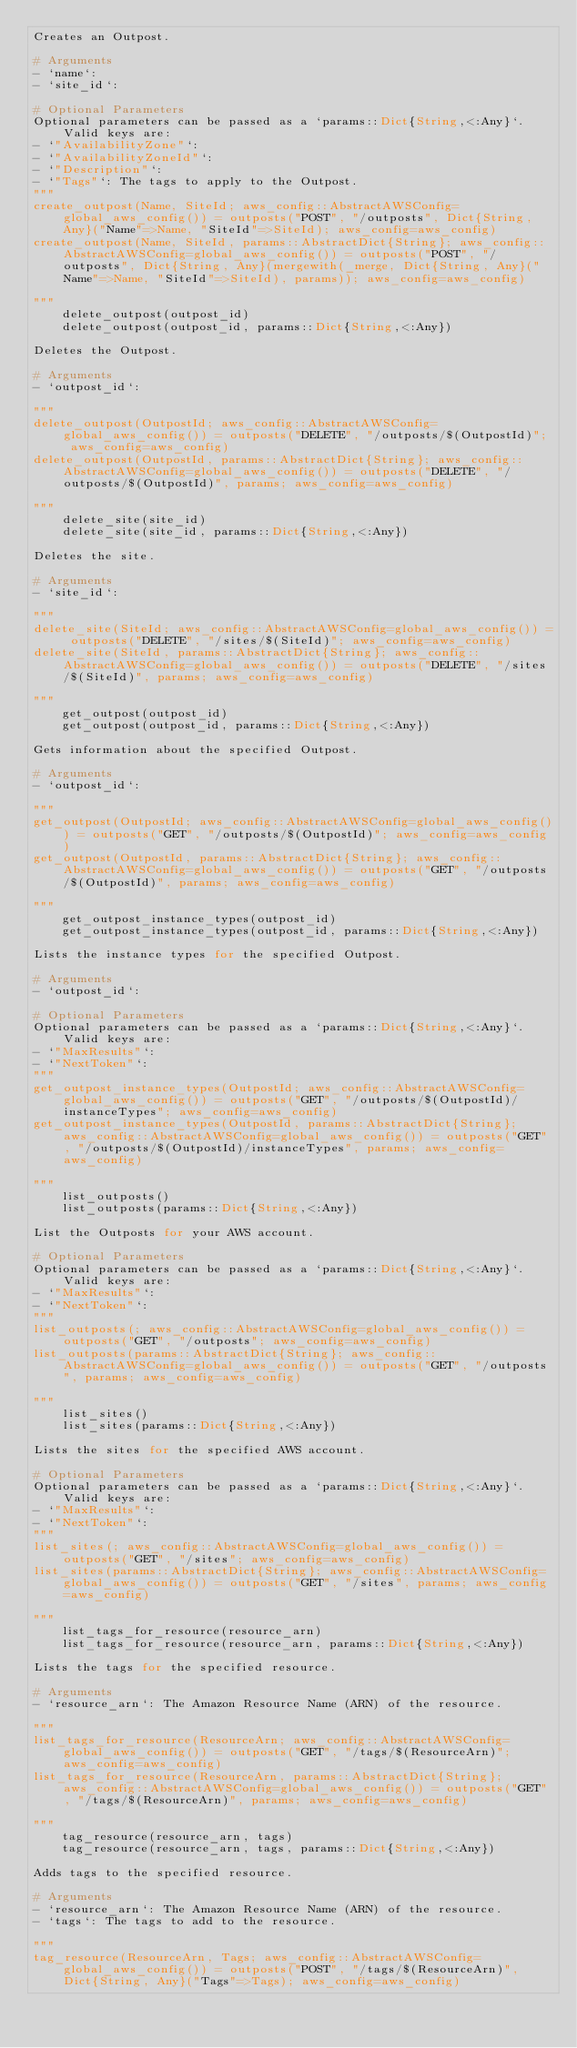Convert code to text. <code><loc_0><loc_0><loc_500><loc_500><_Julia_>Creates an Outpost.

# Arguments
- `name`:
- `site_id`:

# Optional Parameters
Optional parameters can be passed as a `params::Dict{String,<:Any}`. Valid keys are:
- `"AvailabilityZone"`:
- `"AvailabilityZoneId"`:
- `"Description"`:
- `"Tags"`: The tags to apply to the Outpost.
"""
create_outpost(Name, SiteId; aws_config::AbstractAWSConfig=global_aws_config()) = outposts("POST", "/outposts", Dict{String, Any}("Name"=>Name, "SiteId"=>SiteId); aws_config=aws_config)
create_outpost(Name, SiteId, params::AbstractDict{String}; aws_config::AbstractAWSConfig=global_aws_config()) = outposts("POST", "/outposts", Dict{String, Any}(mergewith(_merge, Dict{String, Any}("Name"=>Name, "SiteId"=>SiteId), params)); aws_config=aws_config)

"""
    delete_outpost(outpost_id)
    delete_outpost(outpost_id, params::Dict{String,<:Any})

Deletes the Outpost.

# Arguments
- `outpost_id`:

"""
delete_outpost(OutpostId; aws_config::AbstractAWSConfig=global_aws_config()) = outposts("DELETE", "/outposts/$(OutpostId)"; aws_config=aws_config)
delete_outpost(OutpostId, params::AbstractDict{String}; aws_config::AbstractAWSConfig=global_aws_config()) = outposts("DELETE", "/outposts/$(OutpostId)", params; aws_config=aws_config)

"""
    delete_site(site_id)
    delete_site(site_id, params::Dict{String,<:Any})

Deletes the site.

# Arguments
- `site_id`:

"""
delete_site(SiteId; aws_config::AbstractAWSConfig=global_aws_config()) = outposts("DELETE", "/sites/$(SiteId)"; aws_config=aws_config)
delete_site(SiteId, params::AbstractDict{String}; aws_config::AbstractAWSConfig=global_aws_config()) = outposts("DELETE", "/sites/$(SiteId)", params; aws_config=aws_config)

"""
    get_outpost(outpost_id)
    get_outpost(outpost_id, params::Dict{String,<:Any})

Gets information about the specified Outpost.

# Arguments
- `outpost_id`:

"""
get_outpost(OutpostId; aws_config::AbstractAWSConfig=global_aws_config()) = outposts("GET", "/outposts/$(OutpostId)"; aws_config=aws_config)
get_outpost(OutpostId, params::AbstractDict{String}; aws_config::AbstractAWSConfig=global_aws_config()) = outposts("GET", "/outposts/$(OutpostId)", params; aws_config=aws_config)

"""
    get_outpost_instance_types(outpost_id)
    get_outpost_instance_types(outpost_id, params::Dict{String,<:Any})

Lists the instance types for the specified Outpost.

# Arguments
- `outpost_id`:

# Optional Parameters
Optional parameters can be passed as a `params::Dict{String,<:Any}`. Valid keys are:
- `"MaxResults"`:
- `"NextToken"`:
"""
get_outpost_instance_types(OutpostId; aws_config::AbstractAWSConfig=global_aws_config()) = outposts("GET", "/outposts/$(OutpostId)/instanceTypes"; aws_config=aws_config)
get_outpost_instance_types(OutpostId, params::AbstractDict{String}; aws_config::AbstractAWSConfig=global_aws_config()) = outposts("GET", "/outposts/$(OutpostId)/instanceTypes", params; aws_config=aws_config)

"""
    list_outposts()
    list_outposts(params::Dict{String,<:Any})

List the Outposts for your AWS account.

# Optional Parameters
Optional parameters can be passed as a `params::Dict{String,<:Any}`. Valid keys are:
- `"MaxResults"`:
- `"NextToken"`:
"""
list_outposts(; aws_config::AbstractAWSConfig=global_aws_config()) = outposts("GET", "/outposts"; aws_config=aws_config)
list_outposts(params::AbstractDict{String}; aws_config::AbstractAWSConfig=global_aws_config()) = outposts("GET", "/outposts", params; aws_config=aws_config)

"""
    list_sites()
    list_sites(params::Dict{String,<:Any})

Lists the sites for the specified AWS account.

# Optional Parameters
Optional parameters can be passed as a `params::Dict{String,<:Any}`. Valid keys are:
- `"MaxResults"`:
- `"NextToken"`:
"""
list_sites(; aws_config::AbstractAWSConfig=global_aws_config()) = outposts("GET", "/sites"; aws_config=aws_config)
list_sites(params::AbstractDict{String}; aws_config::AbstractAWSConfig=global_aws_config()) = outposts("GET", "/sites", params; aws_config=aws_config)

"""
    list_tags_for_resource(resource_arn)
    list_tags_for_resource(resource_arn, params::Dict{String,<:Any})

Lists the tags for the specified resource.

# Arguments
- `resource_arn`: The Amazon Resource Name (ARN) of the resource.

"""
list_tags_for_resource(ResourceArn; aws_config::AbstractAWSConfig=global_aws_config()) = outposts("GET", "/tags/$(ResourceArn)"; aws_config=aws_config)
list_tags_for_resource(ResourceArn, params::AbstractDict{String}; aws_config::AbstractAWSConfig=global_aws_config()) = outposts("GET", "/tags/$(ResourceArn)", params; aws_config=aws_config)

"""
    tag_resource(resource_arn, tags)
    tag_resource(resource_arn, tags, params::Dict{String,<:Any})

Adds tags to the specified resource.

# Arguments
- `resource_arn`: The Amazon Resource Name (ARN) of the resource.
- `tags`: The tags to add to the resource.

"""
tag_resource(ResourceArn, Tags; aws_config::AbstractAWSConfig=global_aws_config()) = outposts("POST", "/tags/$(ResourceArn)", Dict{String, Any}("Tags"=>Tags); aws_config=aws_config)</code> 